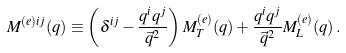Convert formula to latex. <formula><loc_0><loc_0><loc_500><loc_500>M ^ { ( e ) i j } ( q ) \equiv \left ( \delta ^ { i j } - \frac { q ^ { i } q ^ { j } } { \vec { q } ^ { 2 } } \right ) M ^ { ( e ) } _ { T } ( q ) + \frac { q ^ { i } q ^ { j } } { \vec { q } ^ { 2 } } M ^ { ( e ) } _ { L } ( q ) \, .</formula> 